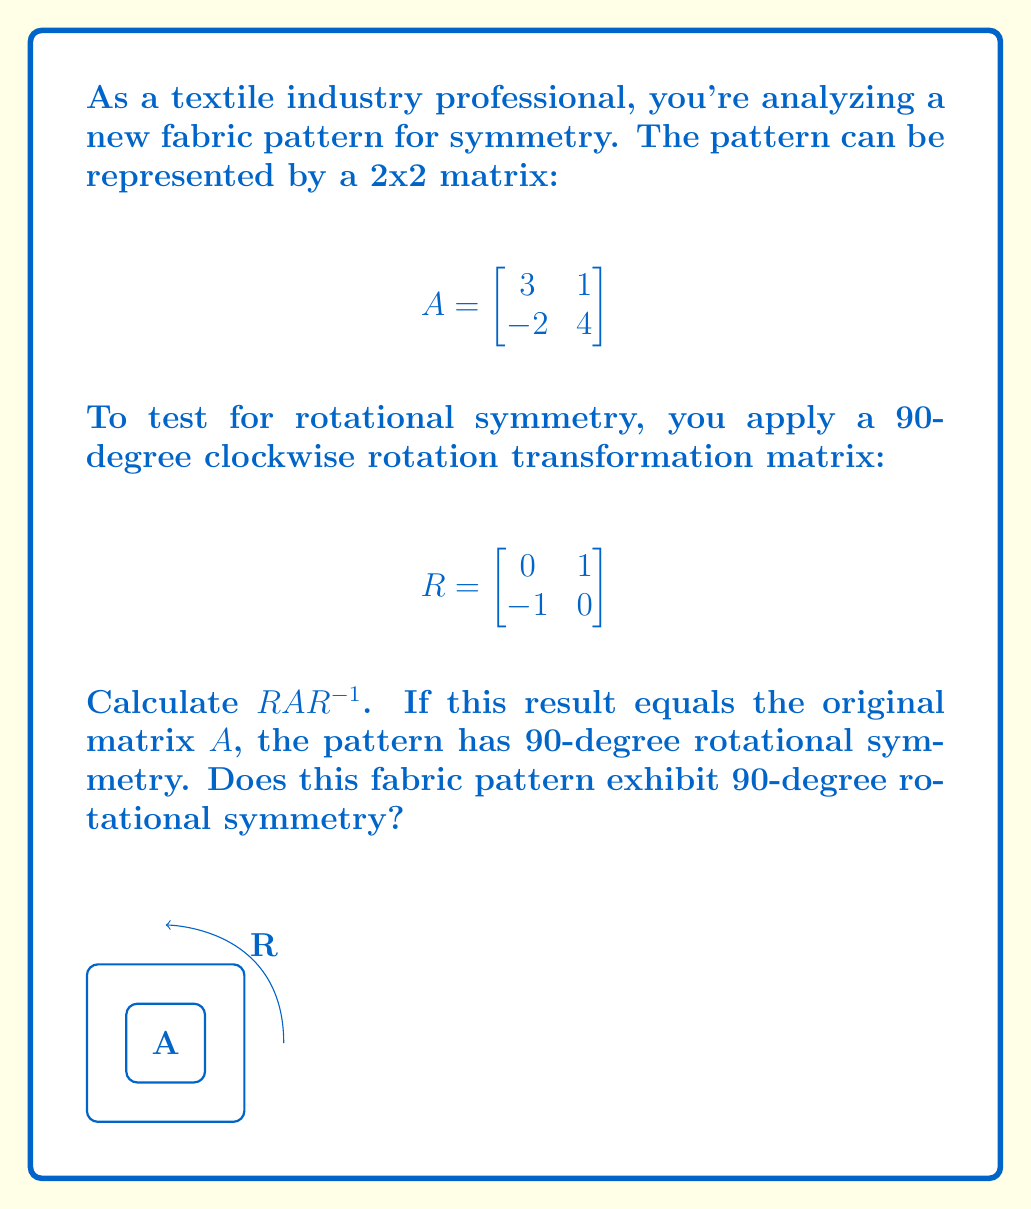Can you answer this question? Let's solve this step-by-step:

1) First, we need to find $R^{-1}$. For a 2x2 rotation matrix, $R^{-1} = R^T$:

   $$R^{-1} = \begin{bmatrix}
   0 & -1 \\
   1 & 0
   \end{bmatrix}$$

2) Now, let's calculate $RAR^{-1}$:

   Step 1: Calculate $RA$
   $$RA = \begin{bmatrix}
   0 & 1 \\
   -1 & 0
   \end{bmatrix}
   \begin{bmatrix}
   3 & 1 \\
   -2 & 4
   \end{bmatrix} =
   \begin{bmatrix}
   -2 & 4 \\
   -3 & -1
   \end{bmatrix}$$

   Step 2: Calculate $(RA)R^{-1}$
   $$RAR^{-1} = \begin{bmatrix}
   -2 & 4 \\
   -3 & -1
   \end{bmatrix}
   \begin{bmatrix}
   0 & -1 \\
   1 & 0
   \end{bmatrix} =
   \begin{bmatrix}
   4 & 2 \\
   1 & 3
   \end{bmatrix}$$

3) Compare the result with the original matrix $A$:

   $$A = \begin{bmatrix}
   3 & 1 \\
   -2 & 4
   \end{bmatrix} \neq \begin{bmatrix}
   4 & 2 \\
   1 & 3
   \end{bmatrix} = RAR^{-1}$$

Since $RAR^{-1} \neq A$, the fabric pattern does not exhibit 90-degree rotational symmetry.
Answer: No, the fabric pattern does not have 90-degree rotational symmetry. 